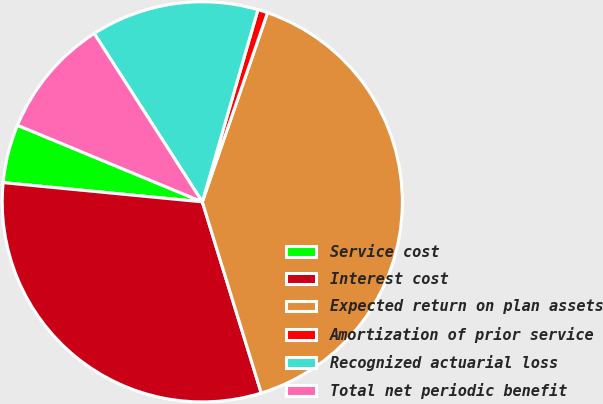Convert chart. <chart><loc_0><loc_0><loc_500><loc_500><pie_chart><fcel>Service cost<fcel>Interest cost<fcel>Expected return on plan assets<fcel>Amortization of prior service<fcel>Recognized actuarial loss<fcel>Total net periodic benefit<nl><fcel>4.72%<fcel>31.29%<fcel>39.95%<fcel>0.8%<fcel>13.57%<fcel>9.66%<nl></chart> 